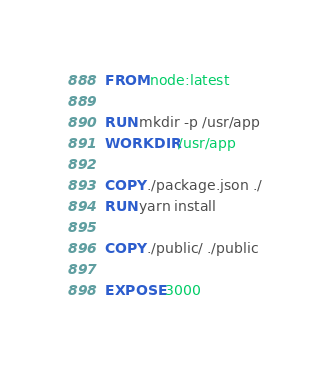<code> <loc_0><loc_0><loc_500><loc_500><_Dockerfile_>FROM node:latest

RUN mkdir -p /usr/app
WORKDIR /usr/app

COPY ./package.json ./
RUN yarn install

COPY ./public/ ./public

EXPOSE 3000
</code> 